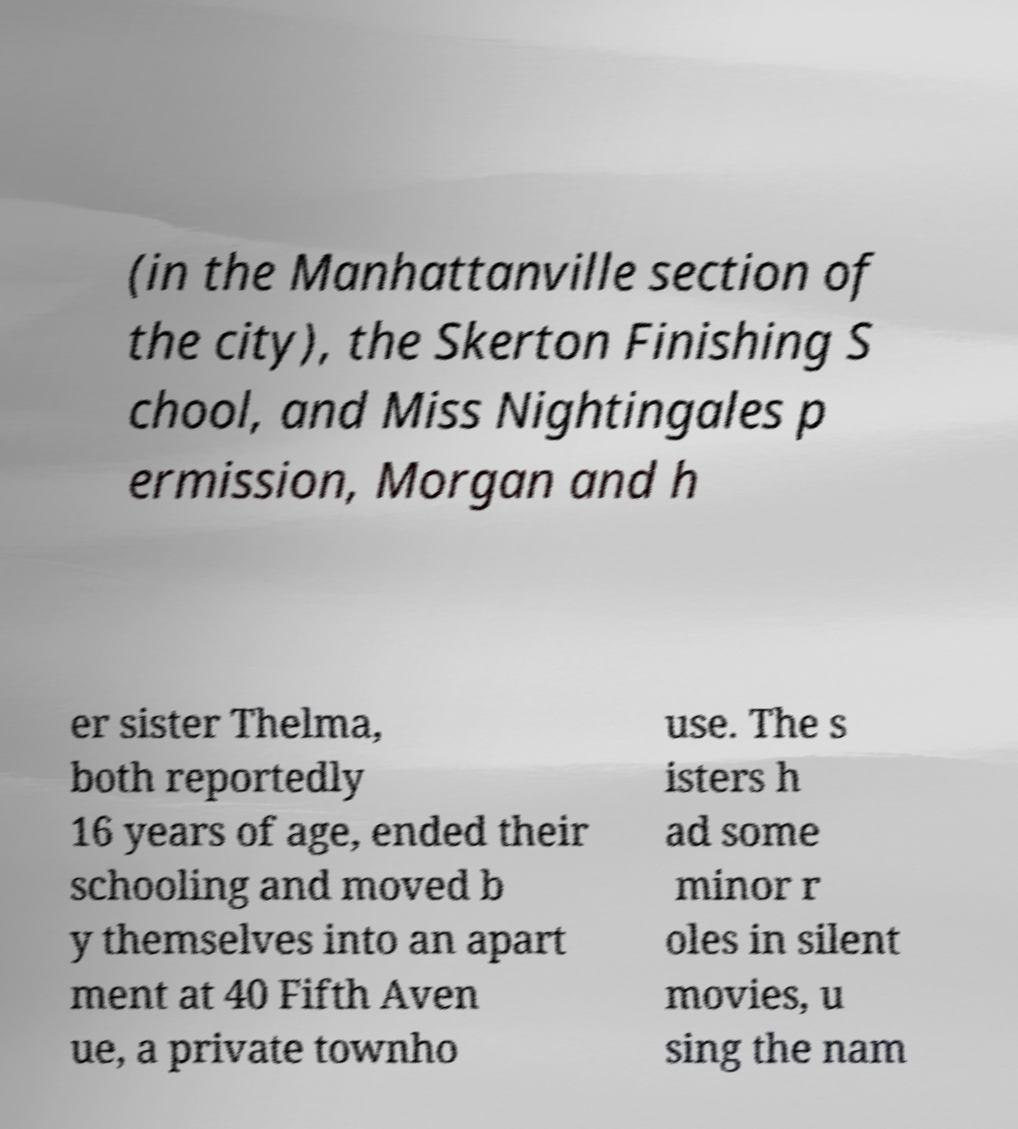For documentation purposes, I need the text within this image transcribed. Could you provide that? (in the Manhattanville section of the city), the Skerton Finishing S chool, and Miss Nightingales p ermission, Morgan and h er sister Thelma, both reportedly 16 years of age, ended their schooling and moved b y themselves into an apart ment at 40 Fifth Aven ue, a private townho use. The s isters h ad some minor r oles in silent movies, u sing the nam 